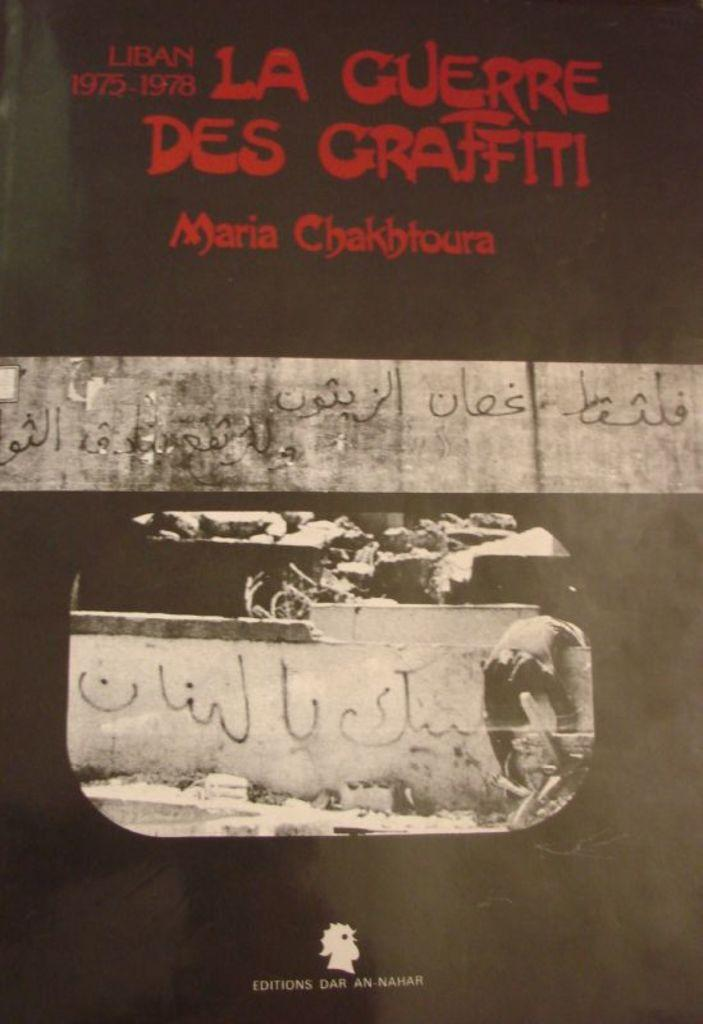<image>
Present a compact description of the photo's key features. A bright red graffiti style font proclaims "La Guerre des Graffiti" by Maria Chakhtoura 